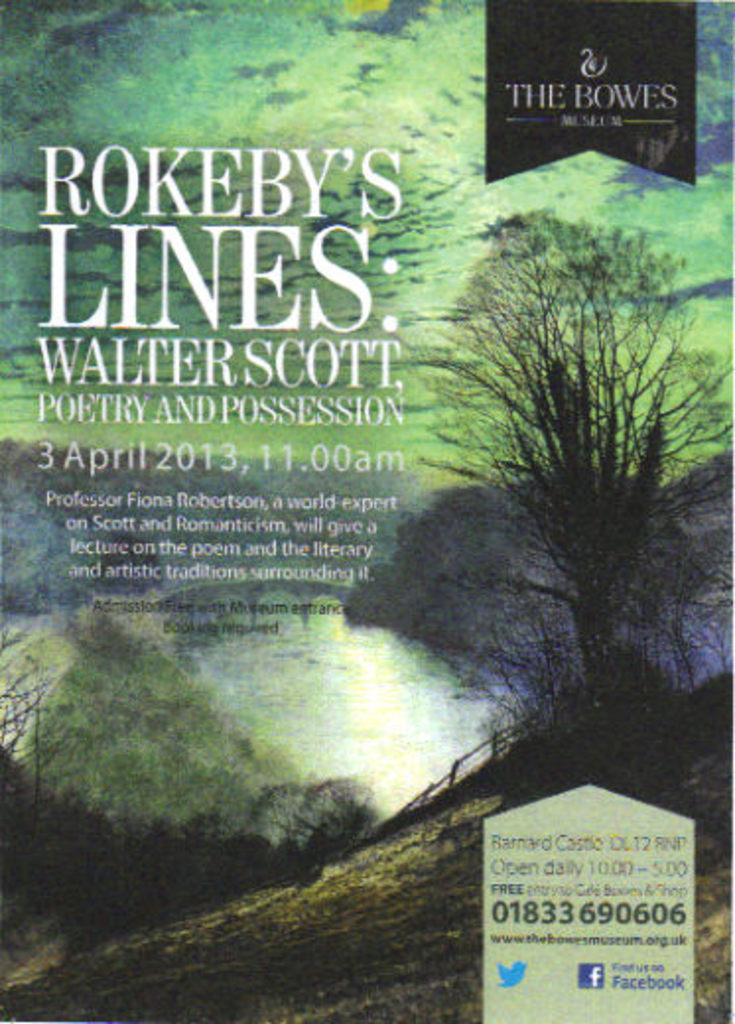Provide a one-sentence caption for the provided image. a book called rokeby's lines about poetry from 2013. 